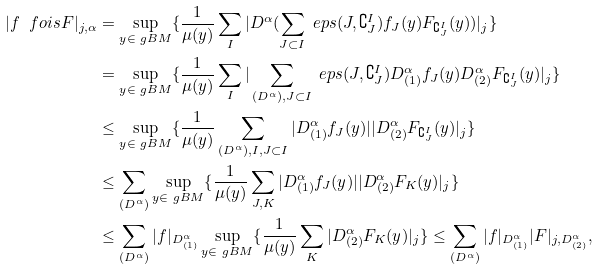Convert formula to latex. <formula><loc_0><loc_0><loc_500><loc_500>| f \ f o i s F | _ { j , \alpha } & = \sup _ { y \in \ g B M } \{ \frac { 1 } { \mu ( y ) } \sum _ { I } | D ^ { \alpha } ( \sum _ { J \subset I } \ e p s ( J , \complement ^ { I } _ { J } ) f _ { J } ( y ) F _ { \complement ^ { I } _ { J } } ( y ) ) | _ { j } \} \\ & = \sup _ { y \in \ g B M } \{ \frac { 1 } { \mu ( y ) } \sum _ { I } | \sum _ { ( D ^ { \alpha } ) , J \subset I } \ e p s ( J , \complement ^ { I } _ { J } ) D ^ { \alpha } _ { ( 1 ) } f _ { J } ( y ) D ^ { \alpha } _ { ( 2 ) } F _ { \complement ^ { I } _ { J } } ( y ) | _ { j } \} \\ & \leq \sup _ { y \in \ g B M } \{ \frac { 1 } { \mu ( y ) } \sum _ { ( D ^ { \alpha } ) , I , J \subset I } | D ^ { \alpha } _ { ( 1 ) } f _ { J } ( y ) | | D ^ { \alpha } _ { ( 2 ) } F _ { \complement ^ { I } _ { J } } ( y ) | _ { j } \} \\ & \leq \sum _ { ( D ^ { \alpha } ) } \sup _ { y \in \ g B M } \{ \frac { 1 } { \mu ( y ) } \sum _ { J , K } | D ^ { \alpha } _ { ( 1 ) } f _ { J } ( y ) | | D ^ { \alpha } _ { ( 2 ) } F _ { K } ( y ) | _ { j } \} \\ & \leq \sum _ { ( D ^ { \alpha } ) } | f | _ { D ^ { \alpha } _ { ( 1 ) } } \sup _ { y \in \ g B M } \{ \frac { 1 } { \mu ( y ) } \sum _ { K } | D ^ { \alpha } _ { ( 2 ) } F _ { K } ( y ) | _ { j } \} \leq \sum _ { ( D ^ { \alpha } ) } | f | _ { D ^ { \alpha } _ { ( 1 ) } } | F | _ { j , D ^ { \alpha } _ { ( 2 ) } } ,</formula> 